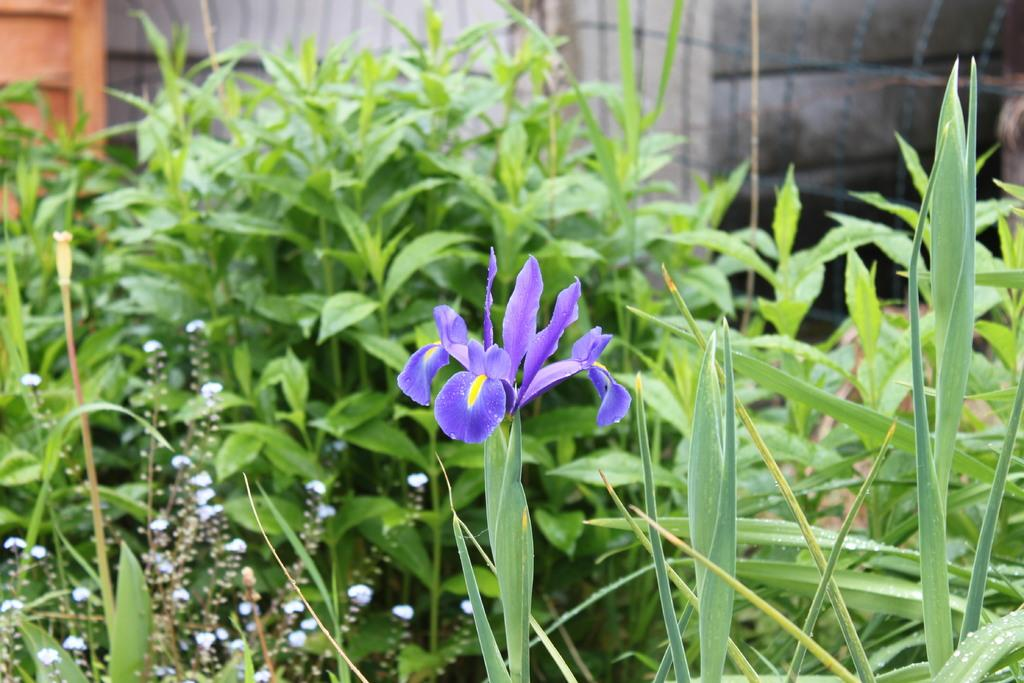What types of vegetation can be seen in the front of the image? There are plants and flowers in the front of the image. What is visible in the background of the image? There is a mesh, a wooden object, and a wall in the background of the image. What group of people can be seen lifting the wooden object in the image? There are no people present in the image, and therefore no group of people can be seen lifting the wooden object. 